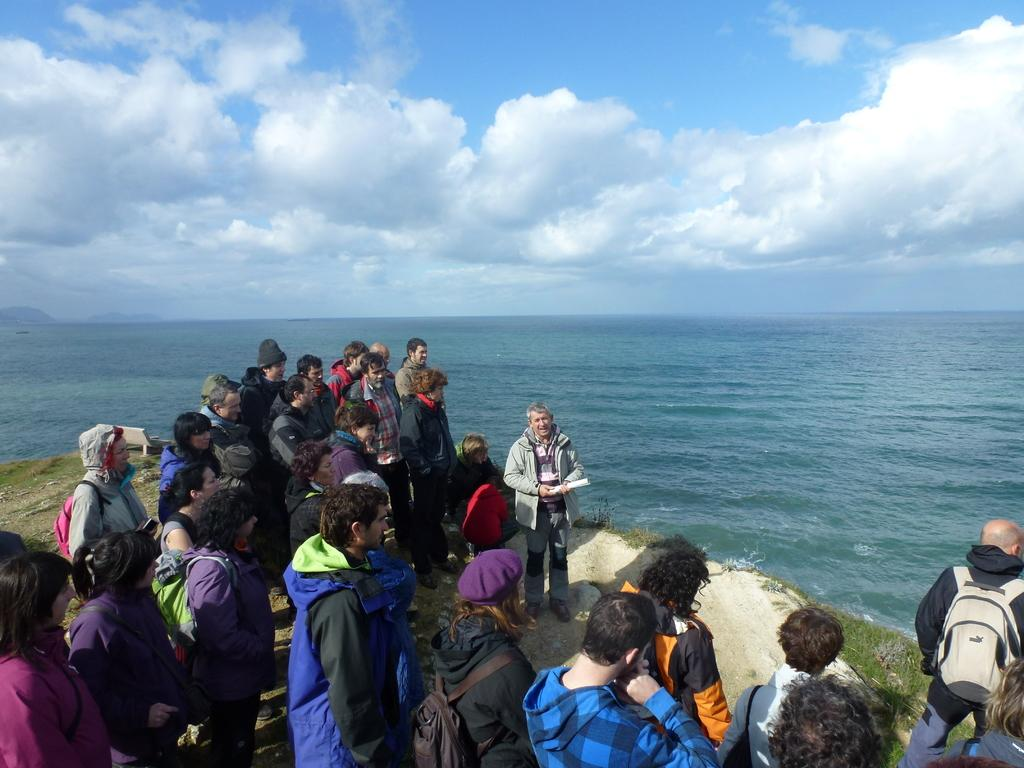What are the people in the image doing? The people in the image are standing on the shore. What is the location of the shore in relation to the sea? The shore is near the sea. What can be seen in the background of the image? There is water visible in the background of the image. What route are the people taking to control the observation in the image? There is no mention of a route, control, or observation in the image. The people are simply standing on the shore near the sea. 